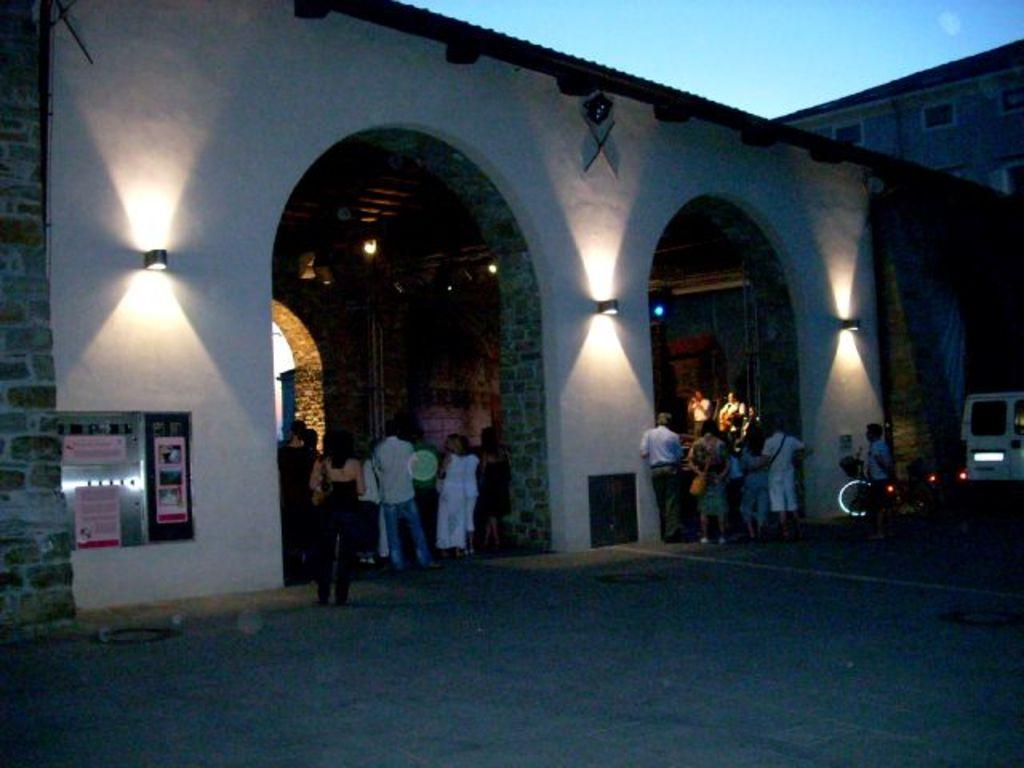What is happening in the image? There are persons standing in the image. What can be seen in the background of the image? There is a white-colored vehicle and buildings in white and cream colors in the background. Can you describe the lighting in the image? Yes, there are lights visible in the image. What type of zephyr is being used by the persons in the image? There is no zephyr present in the image; it is a term related to wind and not applicable to the scene. 